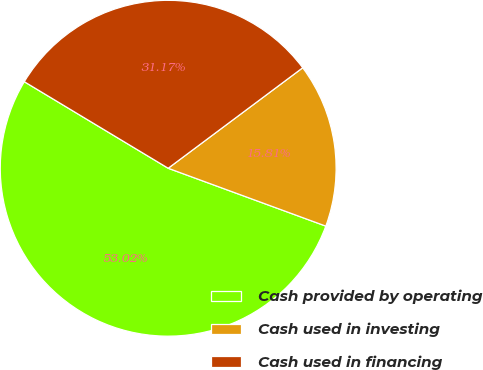Convert chart. <chart><loc_0><loc_0><loc_500><loc_500><pie_chart><fcel>Cash provided by operating<fcel>Cash used in investing<fcel>Cash used in financing<nl><fcel>53.02%<fcel>15.81%<fcel>31.17%<nl></chart> 